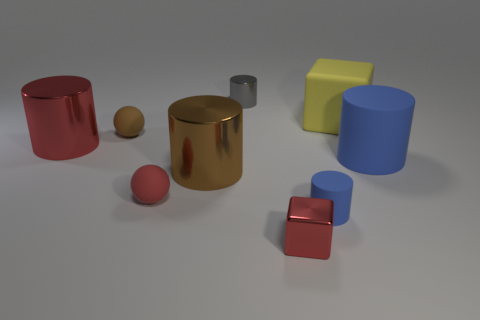Subtract 1 cylinders. How many cylinders are left? 4 Subtract all tiny matte cylinders. How many cylinders are left? 4 Subtract all red cylinders. How many cylinders are left? 4 Subtract all yellow cylinders. Subtract all brown balls. How many cylinders are left? 5 Add 1 big brown matte cubes. How many objects exist? 10 Subtract all cylinders. How many objects are left? 4 Add 9 small cyan blocks. How many small cyan blocks exist? 9 Subtract 1 yellow cubes. How many objects are left? 8 Subtract all small cyan metal things. Subtract all brown things. How many objects are left? 7 Add 5 blue objects. How many blue objects are left? 7 